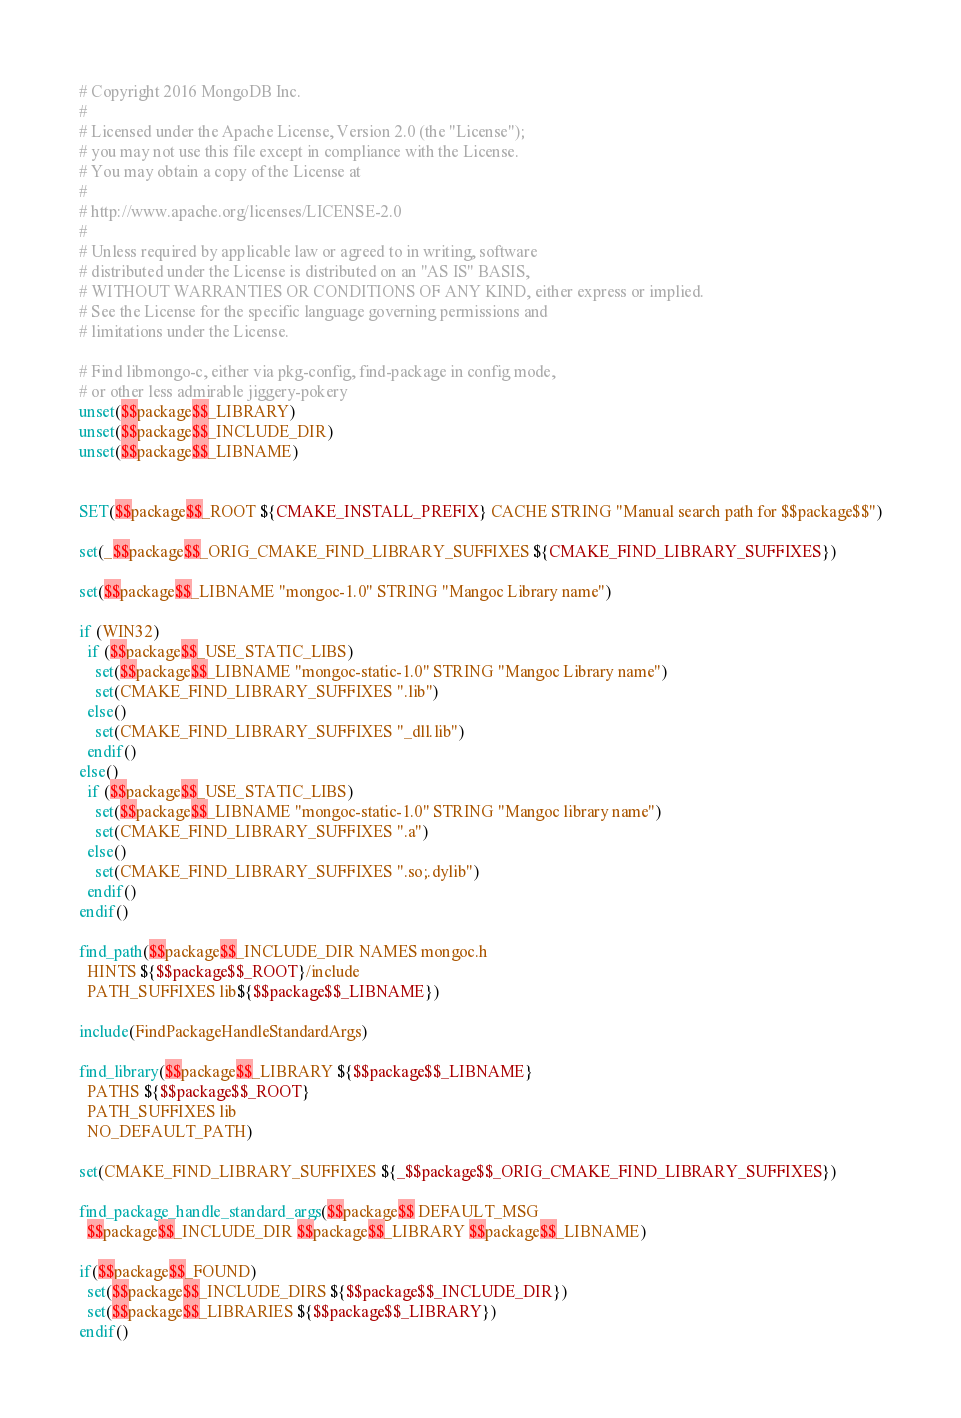Convert code to text. <code><loc_0><loc_0><loc_500><loc_500><_CMake_># Copyright 2016 MongoDB Inc.
#
# Licensed under the Apache License, Version 2.0 (the "License");
# you may not use this file except in compliance with the License.
# You may obtain a copy of the License at
#
# http://www.apache.org/licenses/LICENSE-2.0
#
# Unless required by applicable law or agreed to in writing, software
# distributed under the License is distributed on an "AS IS" BASIS,
# WITHOUT WARRANTIES OR CONDITIONS OF ANY KIND, either express or implied.
# See the License for the specific language governing permissions and
# limitations under the License.

# Find libmongo-c, either via pkg-config, find-package in config mode,
# or other less admirable jiggery-pokery
unset($$package$$_LIBRARY)
unset($$package$$_INCLUDE_DIR)
unset($$package$$_LIBNAME)


SET($$package$$_ROOT ${CMAKE_INSTALL_PREFIX} CACHE STRING "Manual search path for $$package$$")

set(_$$package$$_ORIG_CMAKE_FIND_LIBRARY_SUFFIXES ${CMAKE_FIND_LIBRARY_SUFFIXES})

set($$package$$_LIBNAME "mongoc-1.0" STRING "Mangoc Library name")

if (WIN32)
  if ($$package$$_USE_STATIC_LIBS)
    set($$package$$_LIBNAME "mongoc-static-1.0" STRING "Mangoc Library name")
    set(CMAKE_FIND_LIBRARY_SUFFIXES ".lib")
  else()
    set(CMAKE_FIND_LIBRARY_SUFFIXES "_dll.lib")
  endif()
else()
  if ($$package$$_USE_STATIC_LIBS)
    set($$package$$_LIBNAME "mongoc-static-1.0" STRING "Mangoc library name")
    set(CMAKE_FIND_LIBRARY_SUFFIXES ".a")
  else()
    set(CMAKE_FIND_LIBRARY_SUFFIXES ".so;.dylib")
  endif()
endif()

find_path($$package$$_INCLUDE_DIR NAMES mongoc.h
  HINTS ${$$package$$_ROOT}/include
  PATH_SUFFIXES lib${$$package$$_LIBNAME})

include(FindPackageHandleStandardArgs)

find_library($$package$$_LIBRARY ${$$package$$_LIBNAME}
  PATHS ${$$package$$_ROOT}
  PATH_SUFFIXES lib
  NO_DEFAULT_PATH)

set(CMAKE_FIND_LIBRARY_SUFFIXES ${_$$package$$_ORIG_CMAKE_FIND_LIBRARY_SUFFIXES})

find_package_handle_standard_args($$package$$ DEFAULT_MSG
  $$package$$_INCLUDE_DIR $$package$$_LIBRARY $$package$$_LIBNAME)

if($$package$$_FOUND)
  set($$package$$_INCLUDE_DIRS ${$$package$$_INCLUDE_DIR})
  set($$package$$_LIBRARIES ${$$package$$_LIBRARY})
endif()


</code> 